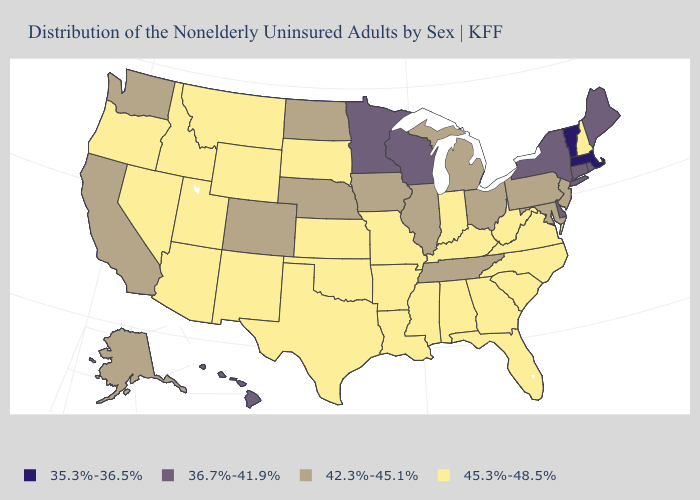Name the states that have a value in the range 35.3%-36.5%?
Short answer required. Massachusetts, Vermont. What is the value of Tennessee?
Answer briefly. 42.3%-45.1%. Name the states that have a value in the range 35.3%-36.5%?
Give a very brief answer. Massachusetts, Vermont. Name the states that have a value in the range 35.3%-36.5%?
Concise answer only. Massachusetts, Vermont. Which states hav the highest value in the South?
Concise answer only. Alabama, Arkansas, Florida, Georgia, Kentucky, Louisiana, Mississippi, North Carolina, Oklahoma, South Carolina, Texas, Virginia, West Virginia. Name the states that have a value in the range 45.3%-48.5%?
Keep it brief. Alabama, Arizona, Arkansas, Florida, Georgia, Idaho, Indiana, Kansas, Kentucky, Louisiana, Mississippi, Missouri, Montana, Nevada, New Hampshire, New Mexico, North Carolina, Oklahoma, Oregon, South Carolina, South Dakota, Texas, Utah, Virginia, West Virginia, Wyoming. What is the value of Montana?
Keep it brief. 45.3%-48.5%. What is the value of Rhode Island?
Concise answer only. 36.7%-41.9%. Which states hav the highest value in the Northeast?
Be succinct. New Hampshire. Name the states that have a value in the range 42.3%-45.1%?
Give a very brief answer. Alaska, California, Colorado, Illinois, Iowa, Maryland, Michigan, Nebraska, New Jersey, North Dakota, Ohio, Pennsylvania, Tennessee, Washington. What is the value of Ohio?
Answer briefly. 42.3%-45.1%. What is the lowest value in the USA?
Short answer required. 35.3%-36.5%. Name the states that have a value in the range 35.3%-36.5%?
Answer briefly. Massachusetts, Vermont. What is the lowest value in the USA?
Write a very short answer. 35.3%-36.5%. How many symbols are there in the legend?
Concise answer only. 4. 